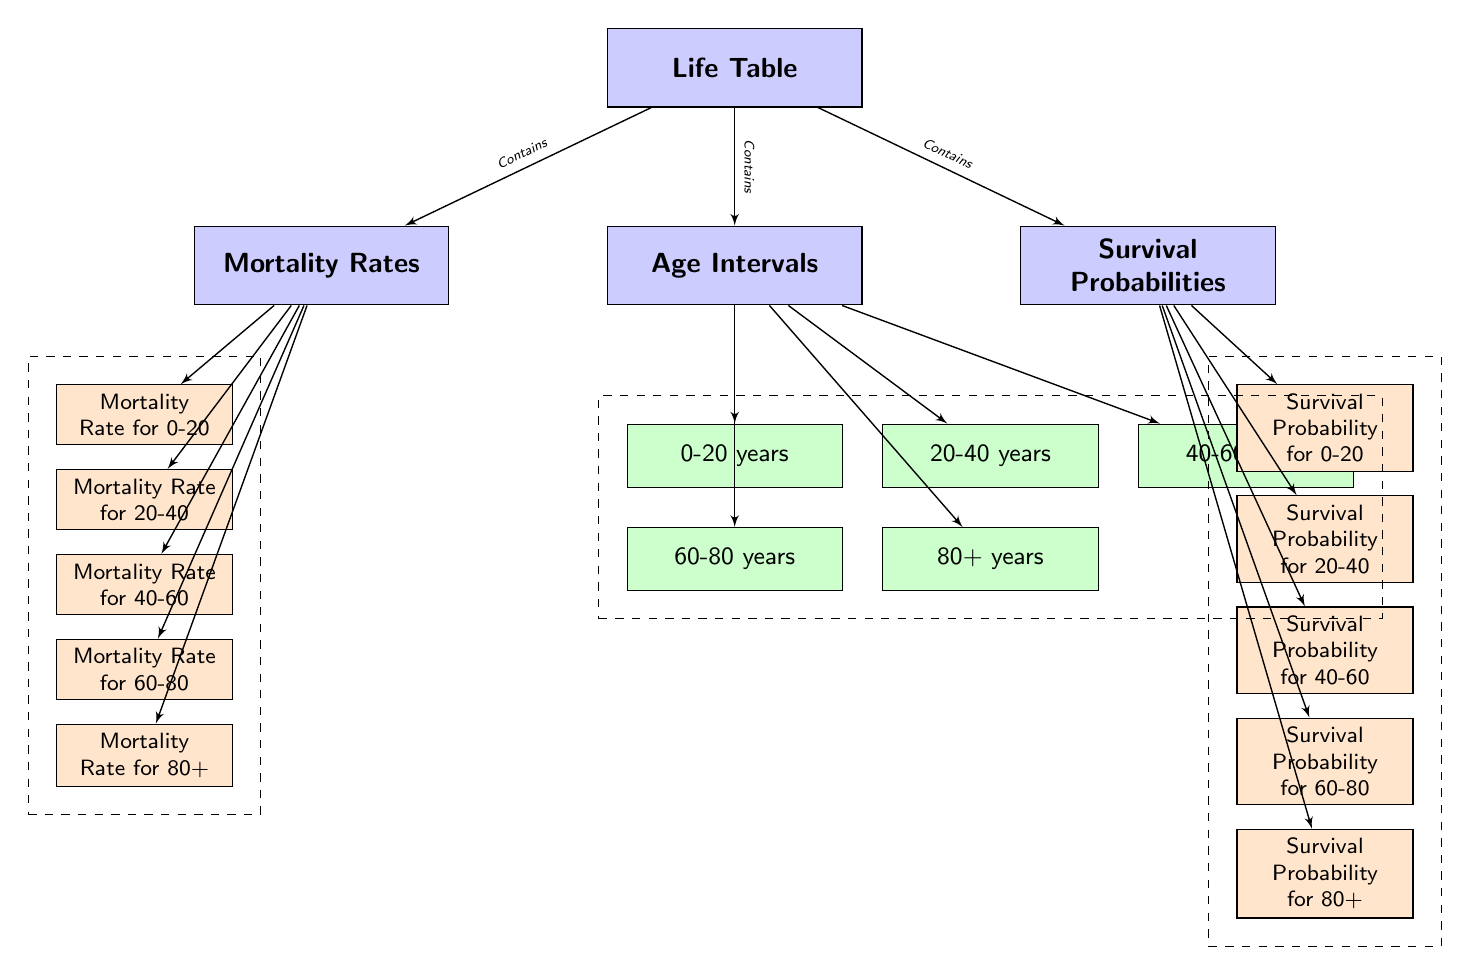What is the title of the diagram? The title is indicated by the main node at the top of the diagram labeled "Life Table."
Answer: Life Table How many age intervals are presented in the diagram? The diagram shows five age intervals, which are displayed as sub-nodes under "Age Intervals."
Answer: 5 What is the relationship between "Life Table" and "Mortality Rates"? The diagram establishes a "Contains" relationship between "Life Table" and "Mortality Rates" as evidenced by the connecting edge labeled as such.
Answer: Contains What is the survival probability for the age group 60-80 years? The diagram contains a specific node labeled "Survival Probability for 60-80" under the "Survival Probabilities" section.
Answer: Survival Probability for 60-80 Which age interval has the lowest mortality rate? To determine this, we observe the nodes under "Mortality Rates" and compare their contents; the specific rates are not displayed, but each age group has a corresponding node. Since the diagram does not provide explicit values, no specific age group can be determined to have the lowest mortality rate within this context.
Answer: Not determined How many nodes are in the "Survival Probabilities" section? The "Survival Probabilities" section includes five nodes representing each age interval's survival probability.
Answer: 5 What is the first age interval listed in the diagram? The first age interval node listed under "Age Intervals" is "0-20 years," positioned at the top of that section.
Answer: 0-20 years What do the dashed boxes represent in this diagram? The dashed boxes in the diagram are used to visually group the related nodes under "Age Intervals," "Mortality Rates," and "Survival Probabilities," indicating that they are collections of information relevant to each category.
Answer: Groups of nodes Which age interval corresponds to the mortality rate node labeled "Mortality Rate for 40-60"? The label indicates a specific age range of 40-60 years, and looking directly at the label provides the corresponding age interval.
Answer: 40-60 years 